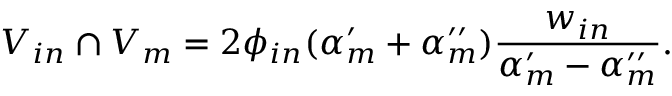Convert formula to latex. <formula><loc_0><loc_0><loc_500><loc_500>V _ { i n } \cap V _ { m } = 2 \phi _ { i n } ( \alpha _ { m } ^ { \prime } + \alpha _ { m } ^ { \prime \prime } ) \frac { w _ { i n } } { \alpha _ { m } ^ { \prime } - \alpha _ { m } ^ { \prime \prime } } .</formula> 